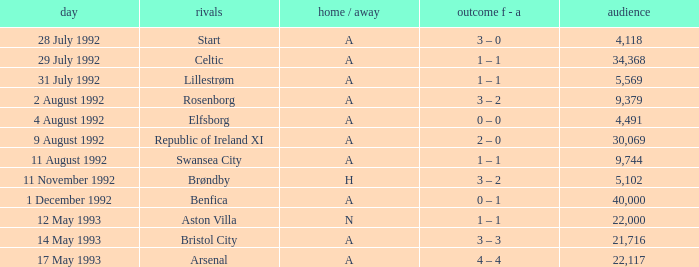Which Result F-A has Opponents of rosenborg? 3 – 2. 